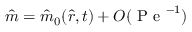Convert formula to latex. <formula><loc_0><loc_0><loc_500><loc_500>\hat { m } = \hat { m } _ { 0 } ( \hat { r } , t ) + O ( P e ^ { - 1 } )</formula> 